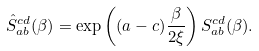Convert formula to latex. <formula><loc_0><loc_0><loc_500><loc_500>\hat { S } _ { a b } ^ { c d } ( \beta ) = \exp \left ( ( a - c ) { \frac { \beta } { 2 \xi } } \right ) S _ { a b } ^ { c d } ( \beta ) .</formula> 